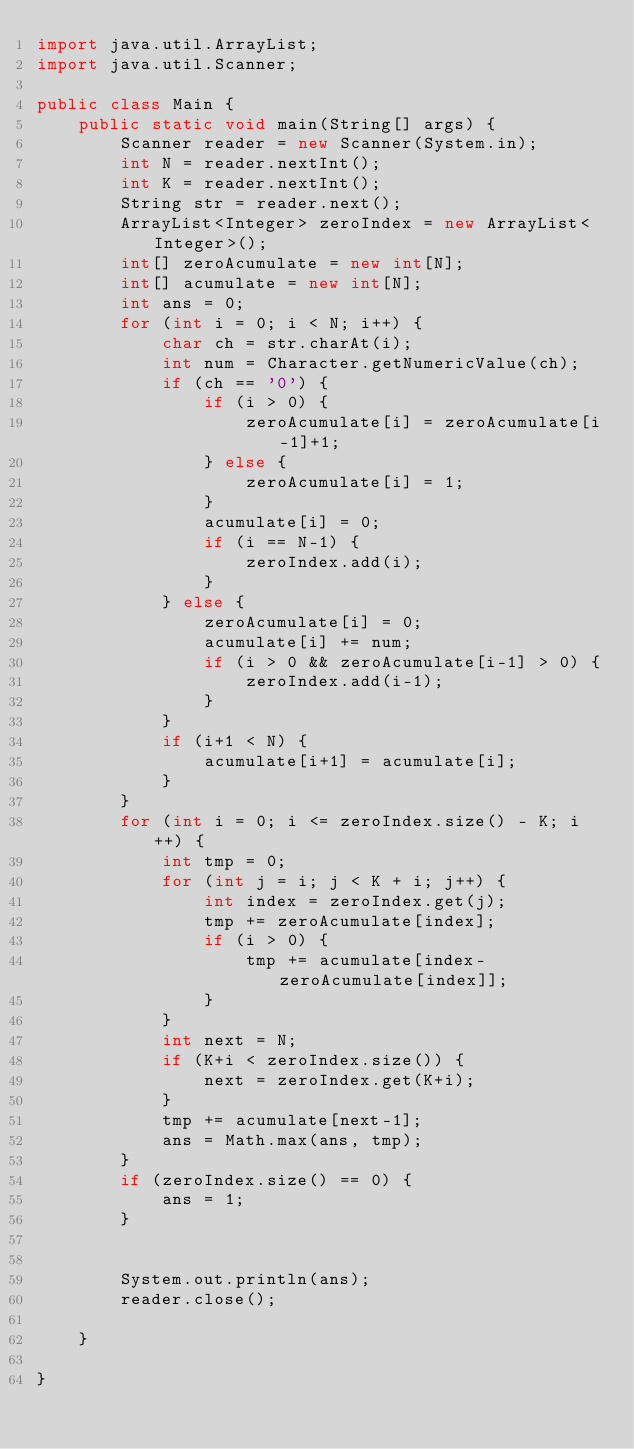Convert code to text. <code><loc_0><loc_0><loc_500><loc_500><_Java_>import java.util.ArrayList;
import java.util.Scanner;

public class Main {
	public static void main(String[] args) {
		Scanner reader = new Scanner(System.in);
		int N = reader.nextInt();
		int K = reader.nextInt();
		String str = reader.next();
		ArrayList<Integer> zeroIndex = new ArrayList<Integer>();
		int[] zeroAcumulate = new int[N];
		int[] acumulate = new int[N];
		int ans = 0;
		for (int i = 0; i < N; i++) {
			char ch = str.charAt(i);
			int num = Character.getNumericValue(ch);
			if (ch == '0') {
				if (i > 0) {
					zeroAcumulate[i] = zeroAcumulate[i-1]+1;
				} else {
					zeroAcumulate[i] = 1;
				}
				acumulate[i] = 0;
				if (i == N-1) {
					zeroIndex.add(i);
				}
			} else {
				zeroAcumulate[i] = 0;
				acumulate[i] += num;
				if (i > 0 && zeroAcumulate[i-1] > 0) {
					zeroIndex.add(i-1);
				}
			}
			if (i+1 < N) {
				acumulate[i+1] = acumulate[i];
			}
		}
		for (int i = 0; i <= zeroIndex.size() - K; i++) {
			int tmp = 0;
			for (int j = i; j < K + i; j++) {
				int index = zeroIndex.get(j);
				tmp += zeroAcumulate[index];
				if (i > 0) {
					tmp += acumulate[index-zeroAcumulate[index]];
				}
			}
			int next = N;
			if (K+i < zeroIndex.size()) {
				next = zeroIndex.get(K+i);
			}
			tmp += acumulate[next-1];
			ans = Math.max(ans, tmp);
		}
		if (zeroIndex.size() == 0) {
			ans = 1;
		}


		System.out.println(ans);
		reader.close();

	}

}



</code> 